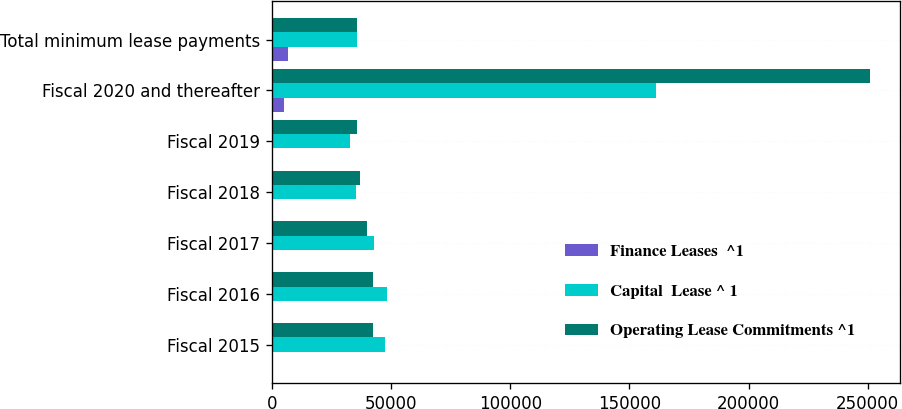<chart> <loc_0><loc_0><loc_500><loc_500><stacked_bar_chart><ecel><fcel>Fiscal 2015<fcel>Fiscal 2016<fcel>Fiscal 2017<fcel>Fiscal 2018<fcel>Fiscal 2019<fcel>Fiscal 2020 and thereafter<fcel>Total minimum lease payments<nl><fcel>Finance Leases  ^1<fcel>304<fcel>333<fcel>354<fcel>354<fcel>354<fcel>5163<fcel>6862<nl><fcel>Capital  Lease ^ 1<fcel>47369<fcel>48219<fcel>42589<fcel>35408<fcel>32577<fcel>160997<fcel>35639<nl><fcel>Operating Lease Commitments ^1<fcel>42341<fcel>42400<fcel>39708<fcel>36890<fcel>35639<fcel>251091<fcel>35639<nl></chart> 